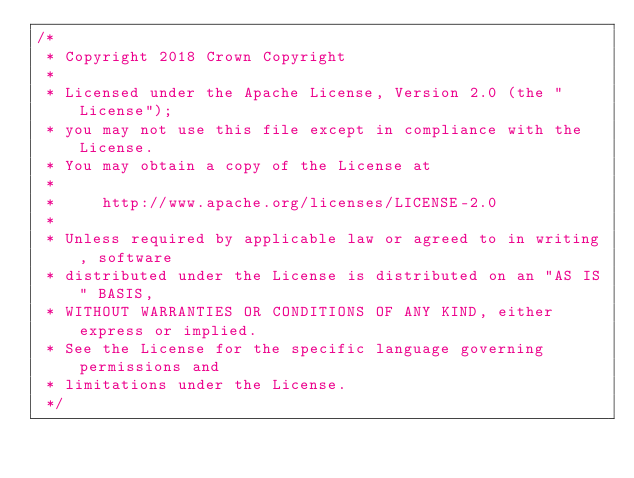<code> <loc_0><loc_0><loc_500><loc_500><_Java_>/*
 * Copyright 2018 Crown Copyright
 *
 * Licensed under the Apache License, Version 2.0 (the "License");
 * you may not use this file except in compliance with the License.
 * You may obtain a copy of the License at
 *
 *     http://www.apache.org/licenses/LICENSE-2.0
 *
 * Unless required by applicable law or agreed to in writing, software
 * distributed under the License is distributed on an "AS IS" BASIS,
 * WITHOUT WARRANTIES OR CONDITIONS OF ANY KIND, either express or implied.
 * See the License for the specific language governing permissions and
 * limitations under the License.
 */
</code> 